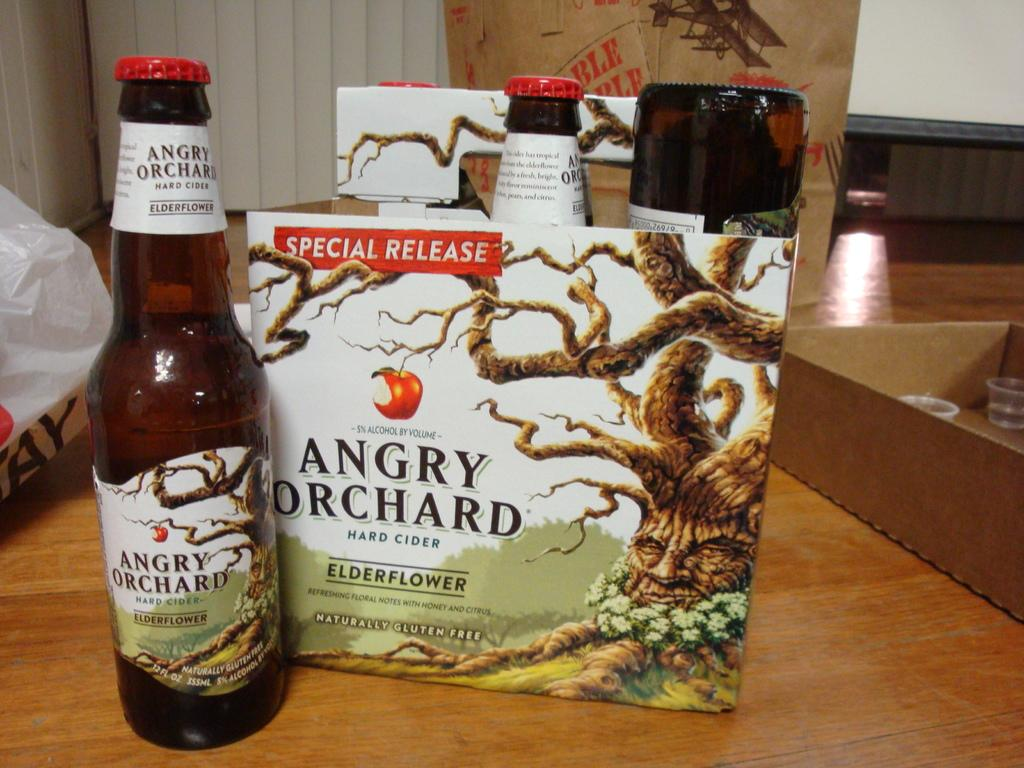<image>
Provide a brief description of the given image. Beer called Angry Orchard next to a box for it. 